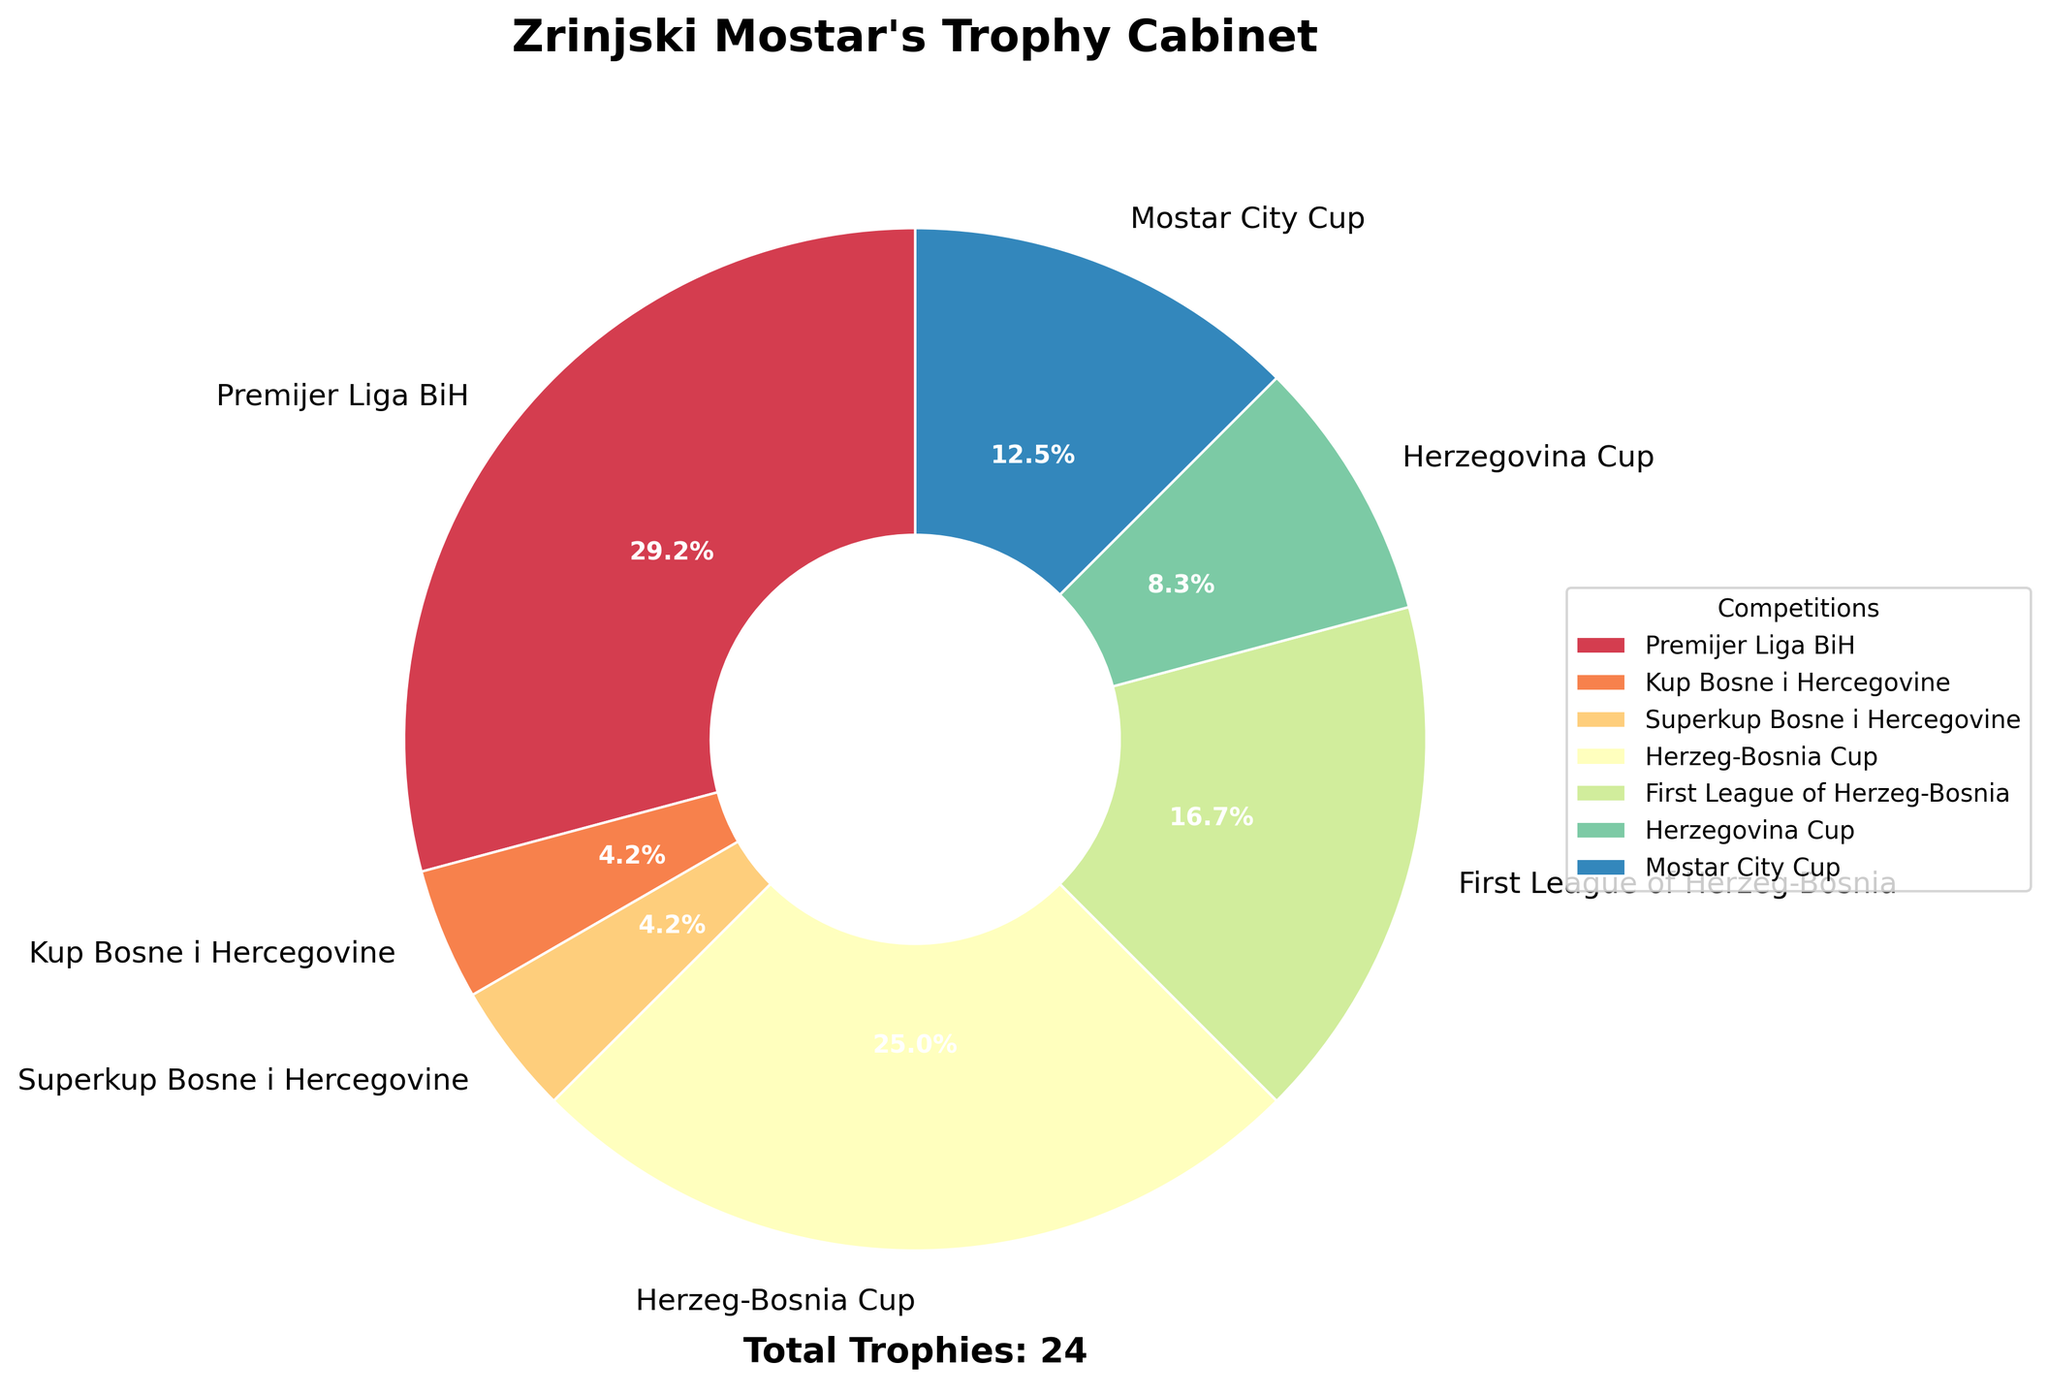What percentage of the trophy cabinet is from winning the Premijer Liga BiH? First, identify the number of Premijer Liga BiH trophies, which is 7. Then, sum all the trophies to get the total: 7 + 1 + 1 + 6 + 4 + 2 + 3 = 24. Calculate the percentage: (7 / 24) * 100 = 29.2%
Answer: 29.2% Which competition has the second-highest number of trophies? The highest number of trophies is in the Premijer Liga BiH with 7. The second-highest is the Herzeg-Bosnia Cup with 6 trophies.
Answer: Herzeg-Bosnia Cup How many more trophies does Zrinjski Mostar have from Premijer Liga BiH compared to the First League of Herzeg-Bosnia? Premijer Liga BiH has 7 trophies, and the First League of Herzeg-Bosnia has 4. Subtract the two amounts: 7 - 4 = 3
Answer: 3 Which trophies have the smallest share of the pie chart, and what is that share? The Kup Bosne i Hercegovine and Superkup Bosne i Hercegovine both have 1 trophy each. Calculate their percentage of the total: (1 / 24) * 100 = 4.2%
Answer: Kup Bosne i Hercegovine and Superkup Bosne i Hercegovine, 4.2% What is the total number of cups won by Zrinjski Mostar in competitions other than the Premijer Liga BiH? Sum the trophies for all competitions except Premijer Liga BiH: 1 (Kup Bosne i Hercegovine) + 1 (Superkup Bosne i Hercegovine) + 6 (Herzeg-Bosnia Cup) + 4 (First League of Herzeg-Bosnia) + 2 (Herzegovina Cup) + 3 (Mostar City Cup) = 17
Answer: 17 What is the combined percentage of trophies from the Herzegovina Cup and Mostar City Cup? The Herzegovina Cup has 2 trophies, and the Mostar City Cup has 3 trophies. Their total is 2 + 3 = 5. Calculate the percentage: (5 / 24) * 100 = 20.8%
Answer: 20.8% How much larger is the share of the Premijer Liga BiH trophies compared to the Superkup Bosne i Hercegovine trophies? The Premijer Liga BiH has 7 trophies, and the Superkup Bosne i Hercegovine has 1. Calculate the difference in share: (7 / 24) * 100 - (1 / 24) * 100 = 29.2% - 4.2% = 25%
Answer: 25% Which competition makes up exactly one-eighth of the trophy cabinet? Calculate one-eighth of the total trophies: 24 / 8 = 3. The Mostar City Cup has 3 trophies, making it one-eighth of the total.
Answer: Mostar City Cup 